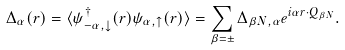Convert formula to latex. <formula><loc_0><loc_0><loc_500><loc_500>\Delta _ { \alpha } ( { r } ) = \langle { \psi } ^ { \dagger } _ { - \alpha , \downarrow } ( { r } ) { \psi } _ { \alpha , \uparrow } ( { r } ) \rangle = \sum _ { \beta = \pm } \Delta _ { \beta N , \alpha } e ^ { i \alpha { r } \cdot { Q } _ { \beta N } } .</formula> 